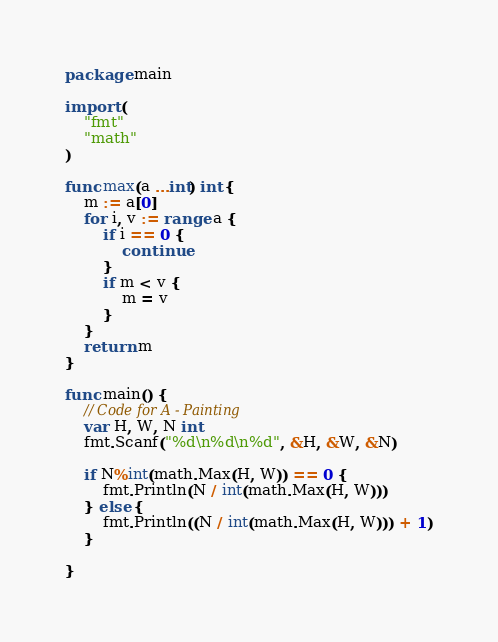Convert code to text. <code><loc_0><loc_0><loc_500><loc_500><_Go_>package main

import (
	"fmt"
	"math"
)

func max(a ...int) int {
	m := a[0]
	for i, v := range a {
		if i == 0 {
			continue
		}
		if m < v {
			m = v
		}
	}
	return m
}

func main() {
	// Code for A - Painting
	var H, W, N int
	fmt.Scanf("%d\n%d\n%d", &H, &W, &N)

	if N%int(math.Max(H, W)) == 0 {
		fmt.Println(N / int(math.Max(H, W)))
	} else {
		fmt.Println((N / int(math.Max(H, W))) + 1)
	}

}
</code> 